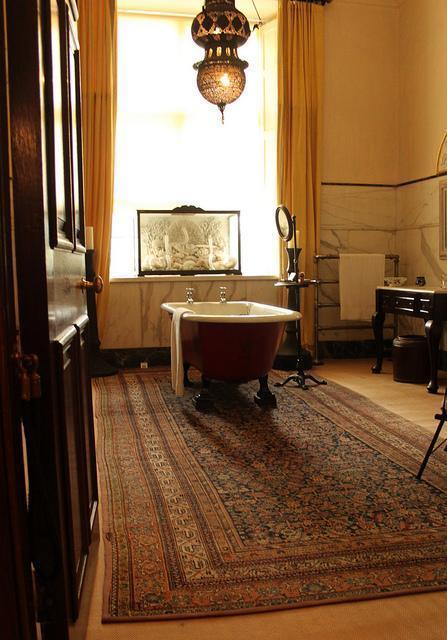How many of the train cars are yellow and red?
Give a very brief answer. 0. 